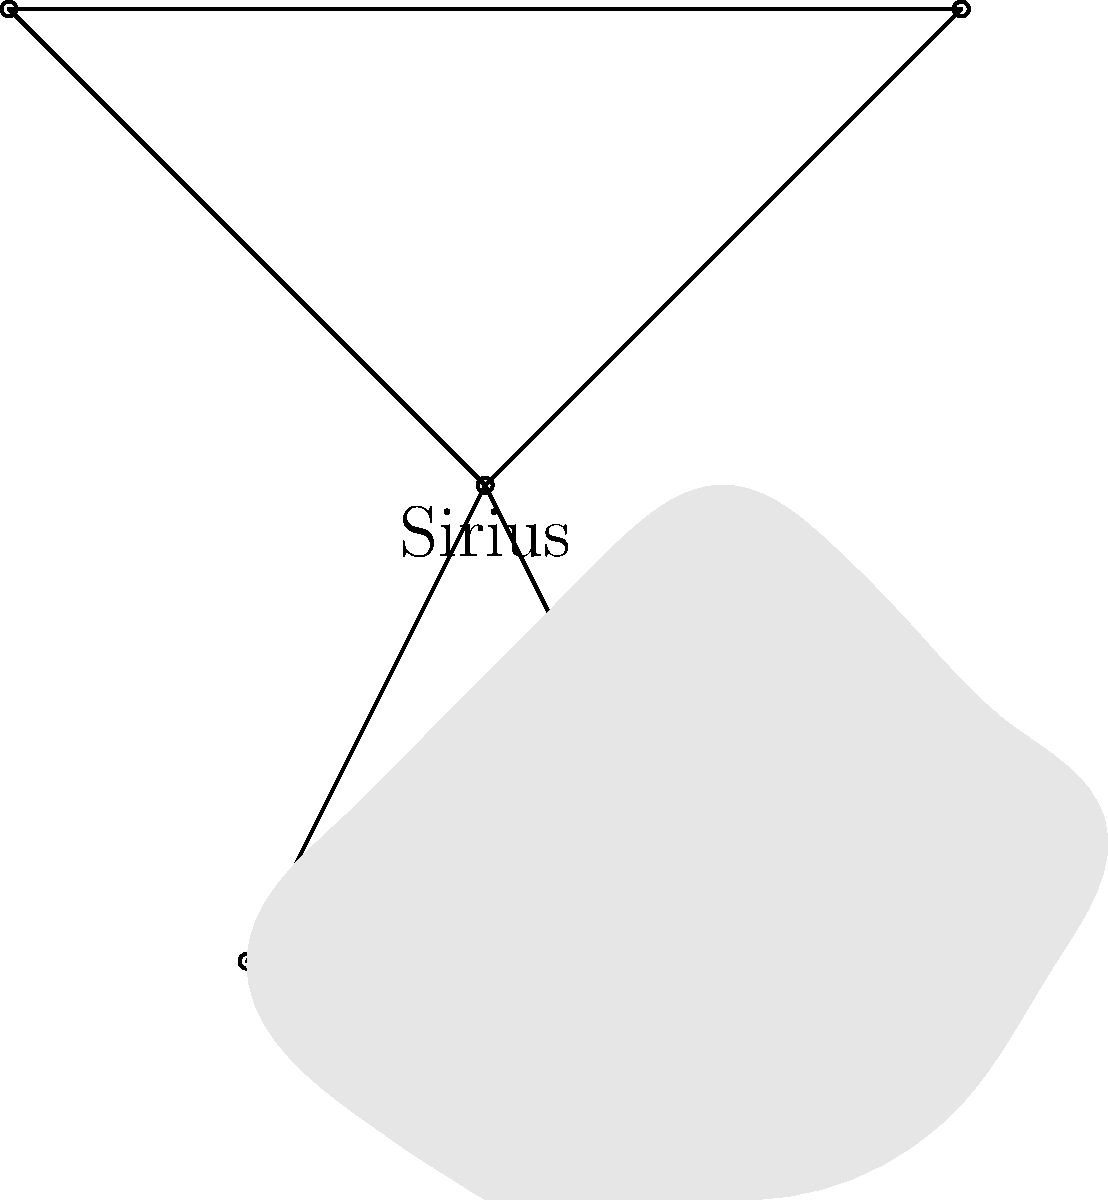In the constellation Canis Major, which star is known for its exceptional brightness and is often referred to as the "Dog Star" in connection with its role in ancient agricultural practices? To answer this question, let's break down the key information:

1. Canis Major is a constellation known as the "Great Dog."
2. The question asks about a particularly bright star in this constellation.
3. This star is referred to as the "Dog Star."
4. It has a connection to ancient agricultural practices.

Step-by-step explanation:

1. The brightest star in Canis Major is Sirius.
2. Sirius is the brightest star in the night sky, with an apparent magnitude of -1.46.
3. Sirius is often called the "Dog Star" because of its prominence in the Canis Major (Great Dog) constellation.
4. In ancient Egypt, the heliacal rising of Sirius (its first appearance in the dawn sky) coincided with the annual flooding of the Nile River, which was crucial for agriculture.
5. The ancient Greeks and Romans associated the appearance of Sirius with the hot summer months, giving rise to the term "dog days of summer."

Given these facts, the star that fits all the criteria in the question is Sirius.
Answer: Sirius 